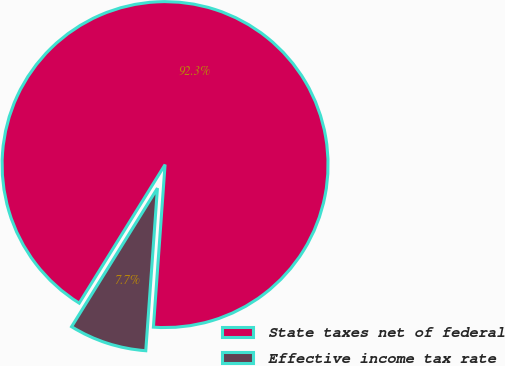Convert chart to OTSL. <chart><loc_0><loc_0><loc_500><loc_500><pie_chart><fcel>State taxes net of federal<fcel>Effective income tax rate<nl><fcel>92.31%<fcel>7.69%<nl></chart> 